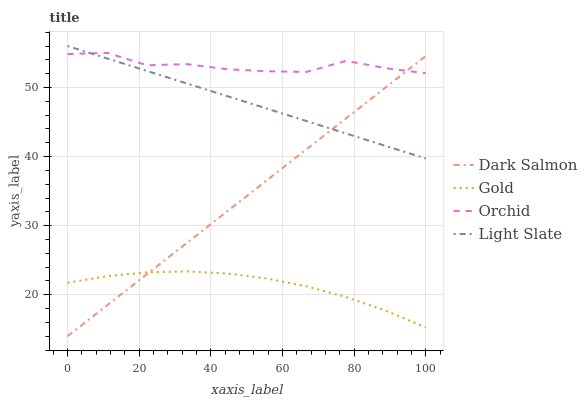Does Dark Salmon have the minimum area under the curve?
Answer yes or no. No. Does Dark Salmon have the maximum area under the curve?
Answer yes or no. No. Is Gold the smoothest?
Answer yes or no. No. Is Gold the roughest?
Answer yes or no. No. Does Gold have the lowest value?
Answer yes or no. No. Does Dark Salmon have the highest value?
Answer yes or no. No. Is Gold less than Orchid?
Answer yes or no. Yes. Is Orchid greater than Gold?
Answer yes or no. Yes. Does Gold intersect Orchid?
Answer yes or no. No. 